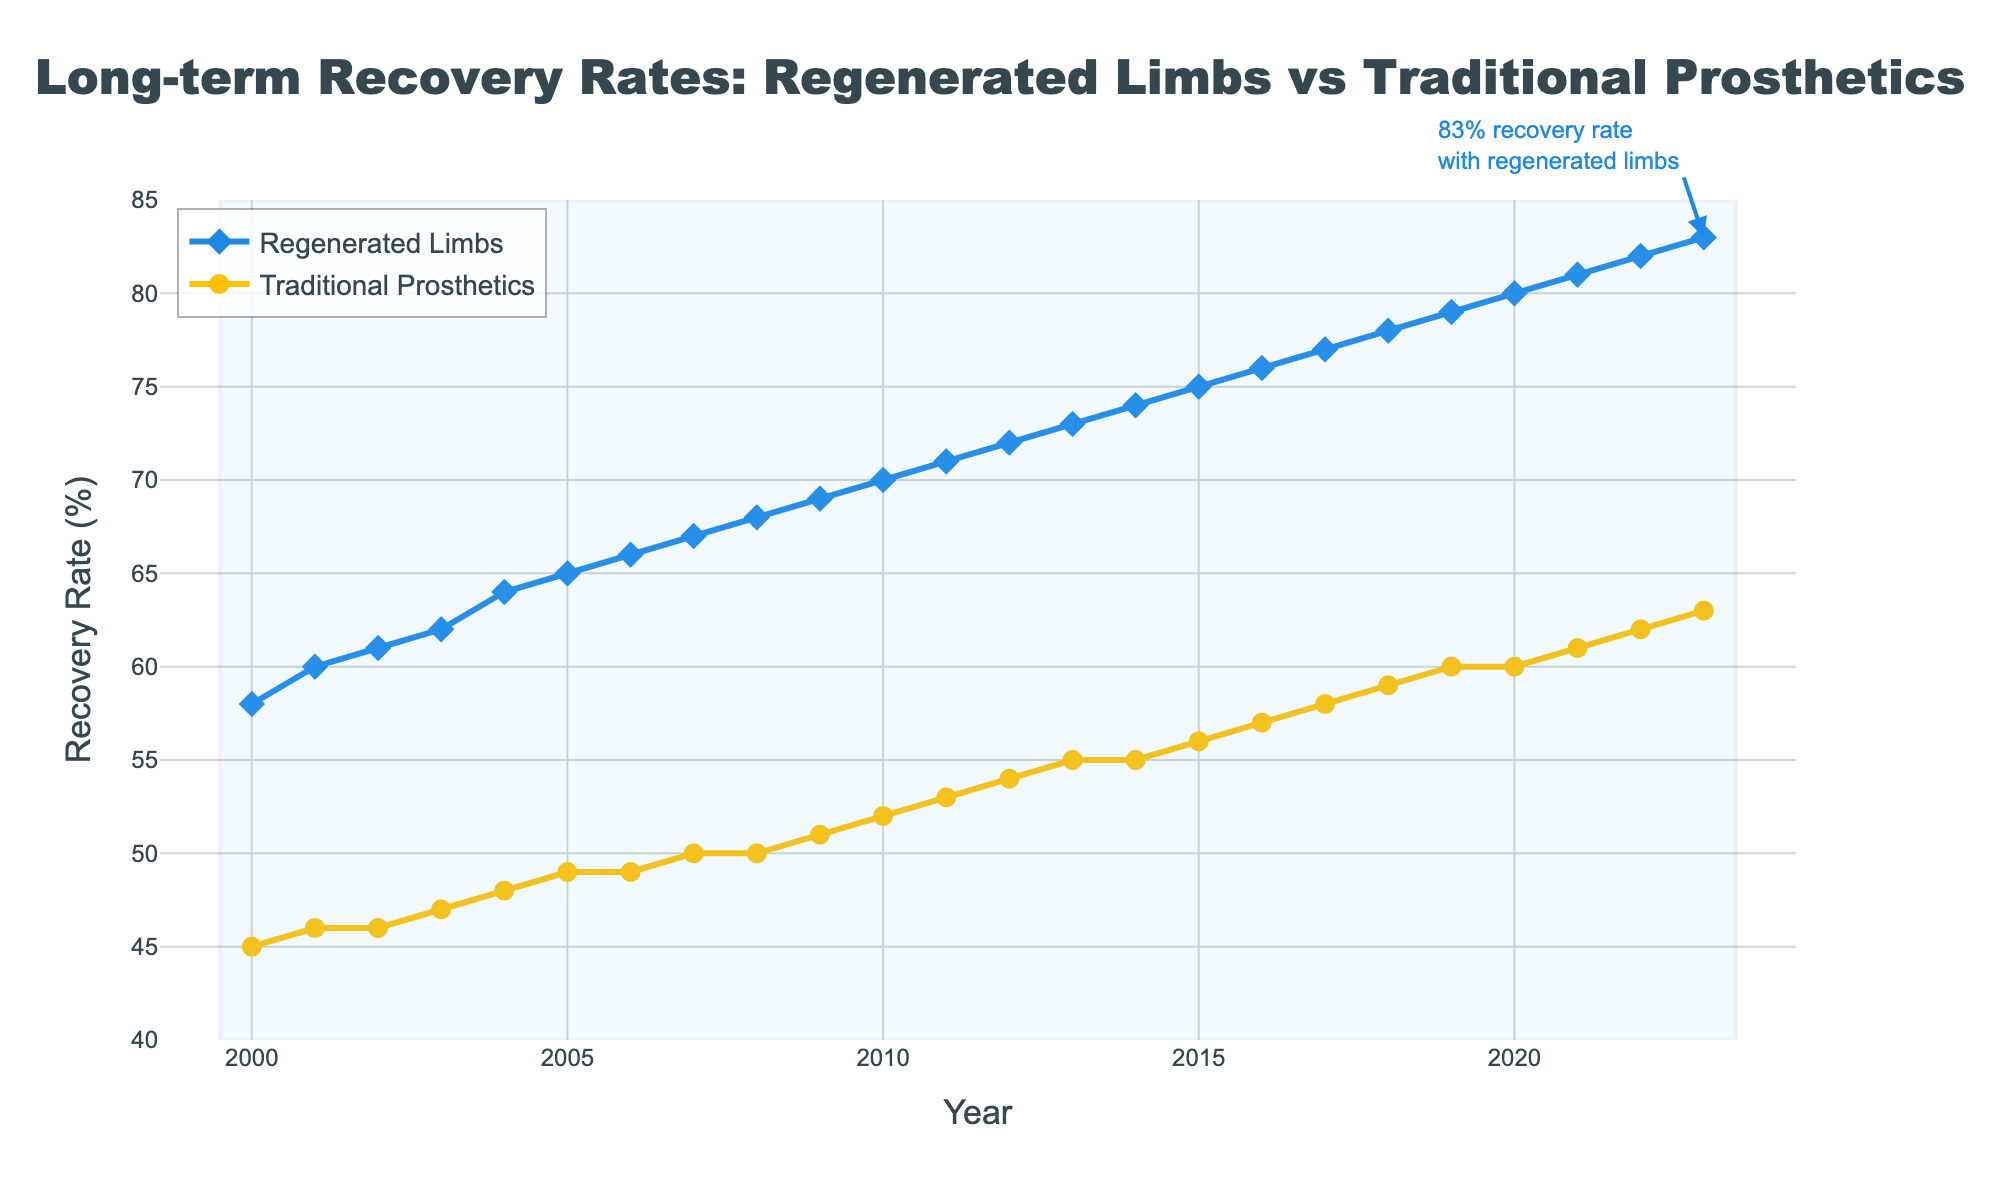What is the title of the plot? The title is located at the top center of the figure and reads "Long-term Recovery Rates: Regenerated Limbs vs Traditional Prosthetics," indicating the comparison of recovery rates over time.
Answer: Long-term Recovery Rates: Regenerated Limbs vs Traditional Prosthetics What are the y-axis labels representing? The y-axis is labeled "Recovery Rate (%)" and shows the recovery rates for both regenerated limbs and traditional prosthetics, indicating the percentage of patients who recover over time.
Answer: Recovery Rate (%) Which year had the highest recovery rate for regenerated limbs? By examining the end of the blue line, which represents regenerated limbs, you will see that it peaks in 2023 at a recovery rate of 83%.
Answer: 2023 How much did the recovery rate for traditional prosthetics increase from 2000 to 2023? The recovery rate for traditional prosthetics in 2000 was 45%, and it increased to 63% in 2023. The increase is calculated by subtracting 45 from 63.
Answer: 18% Which has shown a higher average recovery rate over the period 2000-2023: regenerated limbs or traditional prosthetics? To find the average, sum the yearly recovery rates for each category and divide by the number of years (24). The calculated average for regenerated limbs (sum = 1653) is higher than for traditional prosthetics (sum = 1212).
Answer: Regenerated limbs By how much did the recovery rate for regenerated limbs increase between 2010 and 2020? In 2010, the recovery rate for regenerated limbs was 70%, and in 2020, it was 80%. Subtract the 2010 rate from the 2020 rate (80 - 70) to find the difference.
Answer: 10% In which year did the recovery rates for traditional prosthetics and regenerated limbs increase by similar amounts compared to the previous year? Review the increments year by year. In 2004, both rates increase by 1 percentage point from the previous year (traditional prosthetics: 47% to 48% and regenerated limbs: 62% to 64%).
Answer: 2004 What is the overall trend observed for the recovery rates of both regenerated limbs and traditional prosthetics? Both lines show an upward trend from 2000 to 2023, indicating increasing recovery rates for both treatment types over the years.
Answer: Increasing How much higher was the recovery rate for regenerated limbs compared to traditional prosthetics in 2023? In 2023, the recovery rate for regenerated limbs was 83%, and for traditional prosthetics, it was 63%. The difference is calculated by subtracting 63 from 83.
Answer: 20% What does the blue annotation at the end of the blue line indicate? The blue annotation points to the last data point in the regenerated limbs series and highlights an 83% recovery rate for regenerated limbs in 2023, emphasizing the high recovery performance.
Answer: 83% recovery rate with regenerated limbs 